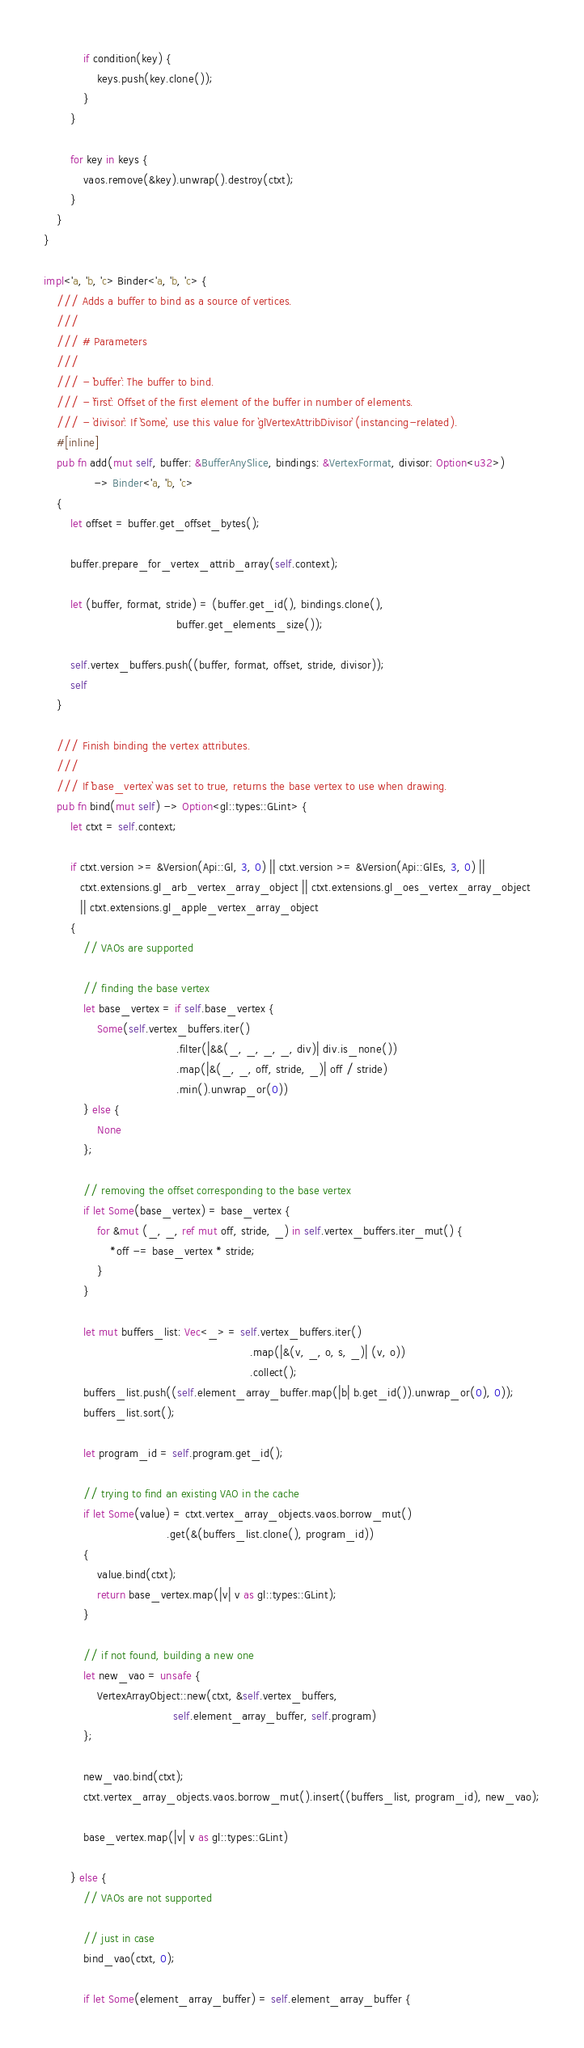<code> <loc_0><loc_0><loc_500><loc_500><_Rust_>            if condition(key) {
                keys.push(key.clone());
            }
        }

        for key in keys {
            vaos.remove(&key).unwrap().destroy(ctxt);
        }
    }
}

impl<'a, 'b, 'c> Binder<'a, 'b, 'c> {
    /// Adds a buffer to bind as a source of vertices.
    ///
    /// # Parameters
    ///
    /// - `buffer`: The buffer to bind.
    /// - `first`: Offset of the first element of the buffer in number of elements.
    /// - `divisor`: If `Some`, use this value for `glVertexAttribDivisor` (instancing-related).
    #[inline]
    pub fn add(mut self, buffer: &BufferAnySlice, bindings: &VertexFormat, divisor: Option<u32>)
               -> Binder<'a, 'b, 'c>
    {
        let offset = buffer.get_offset_bytes();

        buffer.prepare_for_vertex_attrib_array(self.context);

        let (buffer, format, stride) = (buffer.get_id(), bindings.clone(),
                                        buffer.get_elements_size());

        self.vertex_buffers.push((buffer, format, offset, stride, divisor));
        self
    }

    /// Finish binding the vertex attributes.
    ///
    /// If `base_vertex` was set to true, returns the base vertex to use when drawing.
    pub fn bind(mut self) -> Option<gl::types::GLint> {
        let ctxt = self.context;

        if ctxt.version >= &Version(Api::Gl, 3, 0) || ctxt.version >= &Version(Api::GlEs, 3, 0) ||
           ctxt.extensions.gl_arb_vertex_array_object || ctxt.extensions.gl_oes_vertex_array_object
           || ctxt.extensions.gl_apple_vertex_array_object
        {
            // VAOs are supported

            // finding the base vertex
            let base_vertex = if self.base_vertex {
                Some(self.vertex_buffers.iter()
                                        .filter(|&&(_, _, _, _, div)| div.is_none())
                                        .map(|&(_, _, off, stride, _)| off / stride)
                                        .min().unwrap_or(0))
            } else {
                None
            };

            // removing the offset corresponding to the base vertex
            if let Some(base_vertex) = base_vertex {
                for &mut (_, _, ref mut off, stride, _) in self.vertex_buffers.iter_mut() {
                    *off -= base_vertex * stride;
                }
            }

            let mut buffers_list: Vec<_> = self.vertex_buffers.iter()
                                                              .map(|&(v, _, o, s, _)| (v, o))
                                                              .collect();
            buffers_list.push((self.element_array_buffer.map(|b| b.get_id()).unwrap_or(0), 0));
            buffers_list.sort();

            let program_id = self.program.get_id();

            // trying to find an existing VAO in the cache
            if let Some(value) = ctxt.vertex_array_objects.vaos.borrow_mut()
                                     .get(&(buffers_list.clone(), program_id))
            {
                value.bind(ctxt);
                return base_vertex.map(|v| v as gl::types::GLint);
            }

            // if not found, building a new one
            let new_vao = unsafe {
                VertexArrayObject::new(ctxt, &self.vertex_buffers,
                                       self.element_array_buffer, self.program)
            };

            new_vao.bind(ctxt);
            ctxt.vertex_array_objects.vaos.borrow_mut().insert((buffers_list, program_id), new_vao);

            base_vertex.map(|v| v as gl::types::GLint)

        } else {
            // VAOs are not supported

            // just in case
            bind_vao(ctxt, 0);

            if let Some(element_array_buffer) = self.element_array_buffer {</code> 